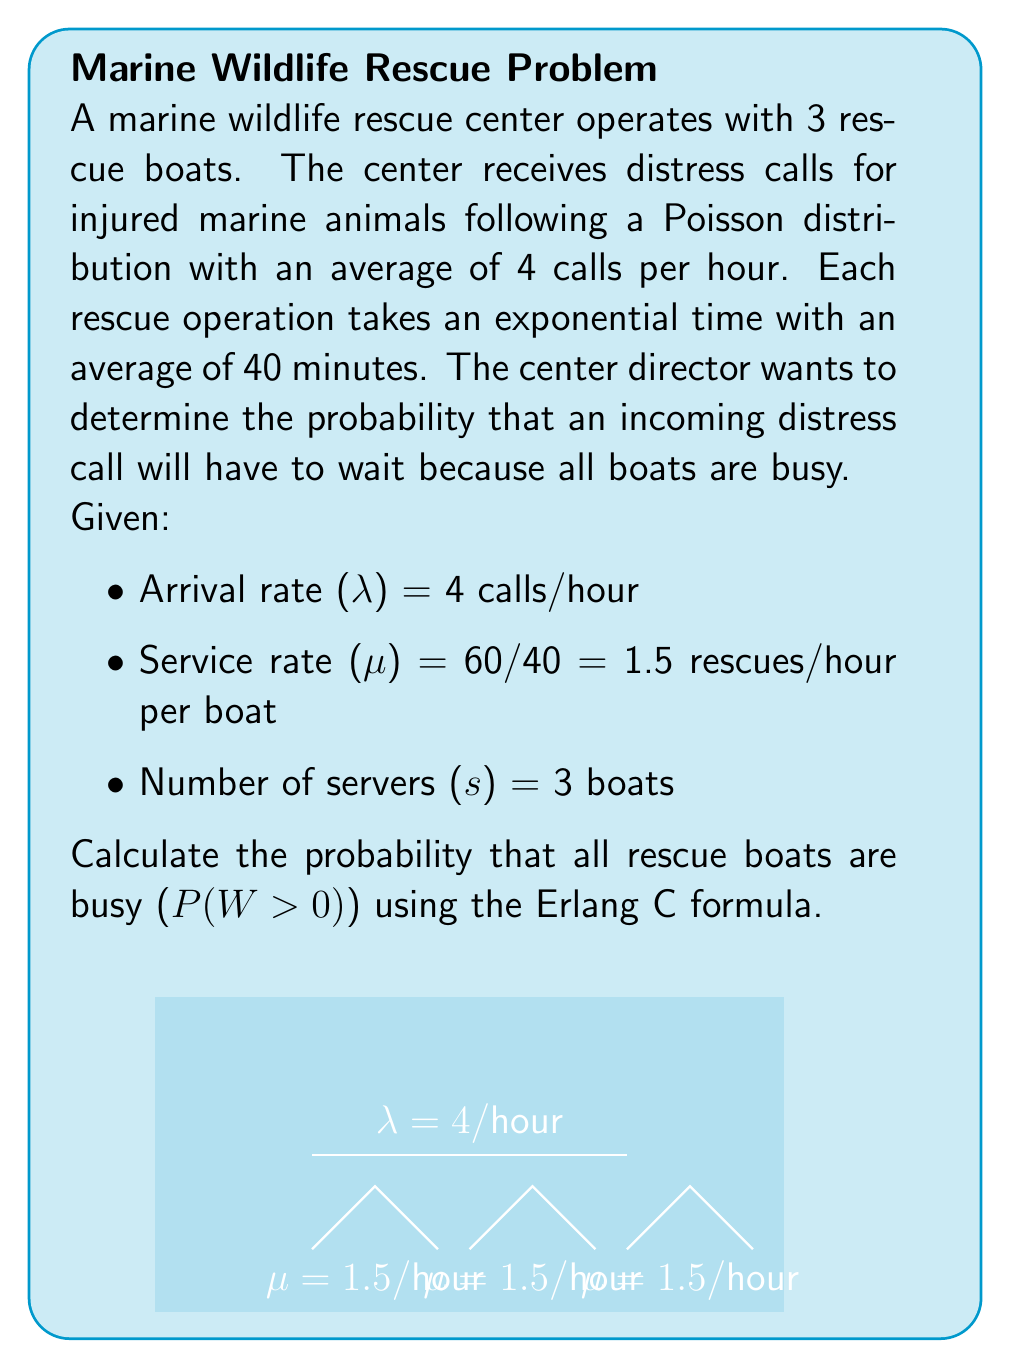Could you help me with this problem? To solve this problem, we'll use the Erlang C formula, which gives the probability that an arriving customer has to wait in an M/M/s queueing system.

Step 1: Calculate the traffic intensity ρ
$$\rho = \frac{\lambda}{s\mu} = \frac{4}{3 \cdot 1.5} = \frac{4}{4.5} \approx 0.8889$$

Step 2: Calculate the Erlang C formula
The Erlang C formula is:

$$C(s,\rho) = \frac{\frac{(s\rho)^s}{s!(1-\rho)}}{\sum_{n=0}^{s-1}\frac{(s\rho)^n}{n!} + \frac{(s\rho)^s}{s!(1-\rho)}}$$

Let's calculate each part:

a) Numerator: 
$$(s\rho)^s = (3 \cdot 0.8889)^3 \approx 5.9328$$
$$s! = 3! = 6$$
$$\frac{(s\rho)^s}{s!(1-\rho)} = \frac{5.9328}{6(1-0.8889)} \approx 8.8992$$

b) Denominator:
$$\sum_{n=0}^{2}\frac{(s\rho)^n}{n!} = 1 + \frac{3 \cdot 0.8889}{1} + \frac{(3 \cdot 0.8889)^2}{2} \approx 4.2666$$

Adding the numerator term:
$$4.2666 + 8.8992 = 13.1658$$

Step 3: Calculate the final probability
$$C(3,0.8889) = \frac{8.8992}{13.1658} \approx 0.6759$$

Therefore, the probability that an incoming distress call will have to wait because all boats are busy is approximately 0.6759 or 67.59%.
Answer: 0.6759 